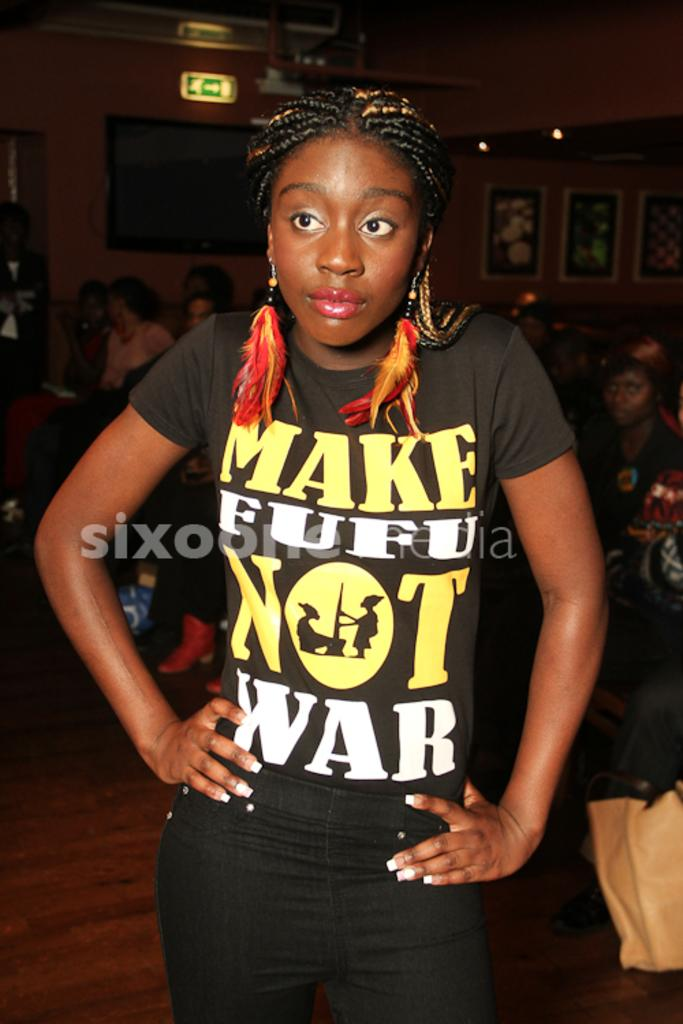<image>
Render a clear and concise summary of the photo. Girl wearing a black shirt with Make Fufu Not War in yellow and white letters. 